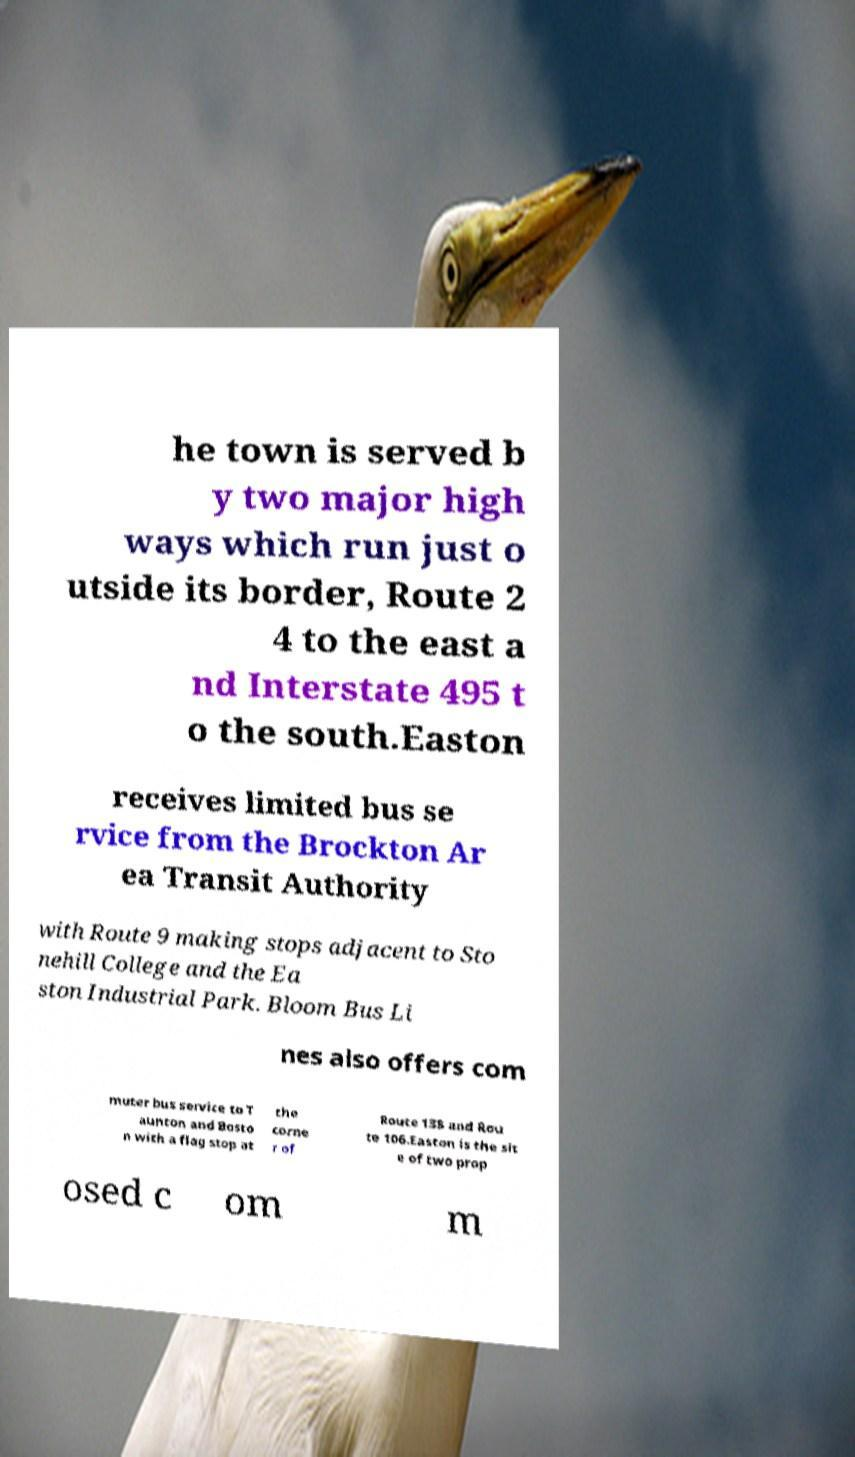Please identify and transcribe the text found in this image. he town is served b y two major high ways which run just o utside its border, Route 2 4 to the east a nd Interstate 495 t o the south.Easton receives limited bus se rvice from the Brockton Ar ea Transit Authority with Route 9 making stops adjacent to Sto nehill College and the Ea ston Industrial Park. Bloom Bus Li nes also offers com muter bus service to T aunton and Bosto n with a flag stop at the corne r of Route 138 and Rou te 106.Easton is the sit e of two prop osed c om m 